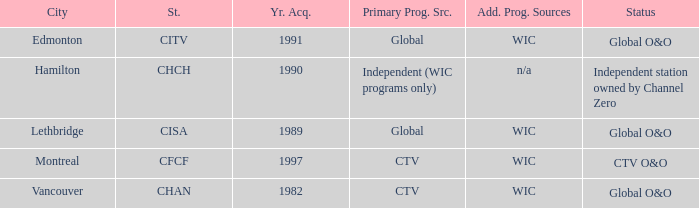Which station is located in edmonton CITV. 